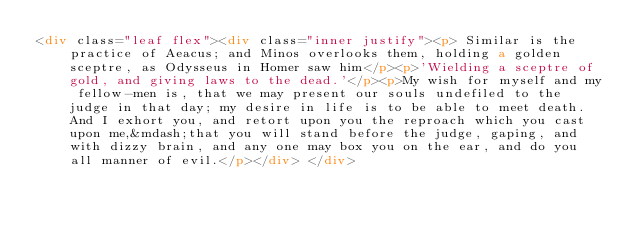Convert code to text. <code><loc_0><loc_0><loc_500><loc_500><_HTML_><div class="leaf flex"><div class="inner justify"><p> Similar is the practice of Aeacus; and Minos overlooks them, holding a golden sceptre, as Odysseus in Homer saw him</p><p>'Wielding a sceptre of gold, and giving laws to the dead.'</p><p>My wish for myself and my fellow-men is, that we may present our souls undefiled to the judge in that day; my desire in life is to be able to meet death. And I exhort you, and retort upon you the reproach which you cast upon me,&mdash;that you will stand before the judge, gaping, and with dizzy brain, and any one may box you on the ear, and do you all manner of evil.</p></div> </div></code> 